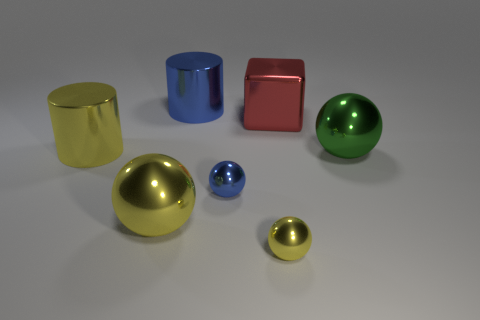There is another cylinder that is the same size as the yellow cylinder; what is it made of?
Your answer should be compact. Metal. Is there a small cyan object that has the same material as the small yellow sphere?
Offer a very short reply. No. Are there fewer small yellow metallic objects behind the big yellow metal sphere than blue things?
Give a very brief answer. Yes. The red block that is behind the tiny sphere that is in front of the blue metallic ball is made of what material?
Offer a terse response. Metal. There is a metallic object that is both to the right of the small blue object and on the left side of the red thing; what shape is it?
Provide a short and direct response. Sphere. How many other things are the same color as the large cube?
Provide a succinct answer. 0. How many things are shiny cylinders in front of the blue cylinder or small cyan spheres?
Give a very brief answer. 1. There is a big block; does it have the same color as the ball to the right of the small yellow ball?
Ensure brevity in your answer.  No. Is there any other thing that is the same size as the metallic cube?
Keep it short and to the point. Yes. What size is the cylinder on the left side of the metal cylinder behind the big red thing?
Your response must be concise. Large. 